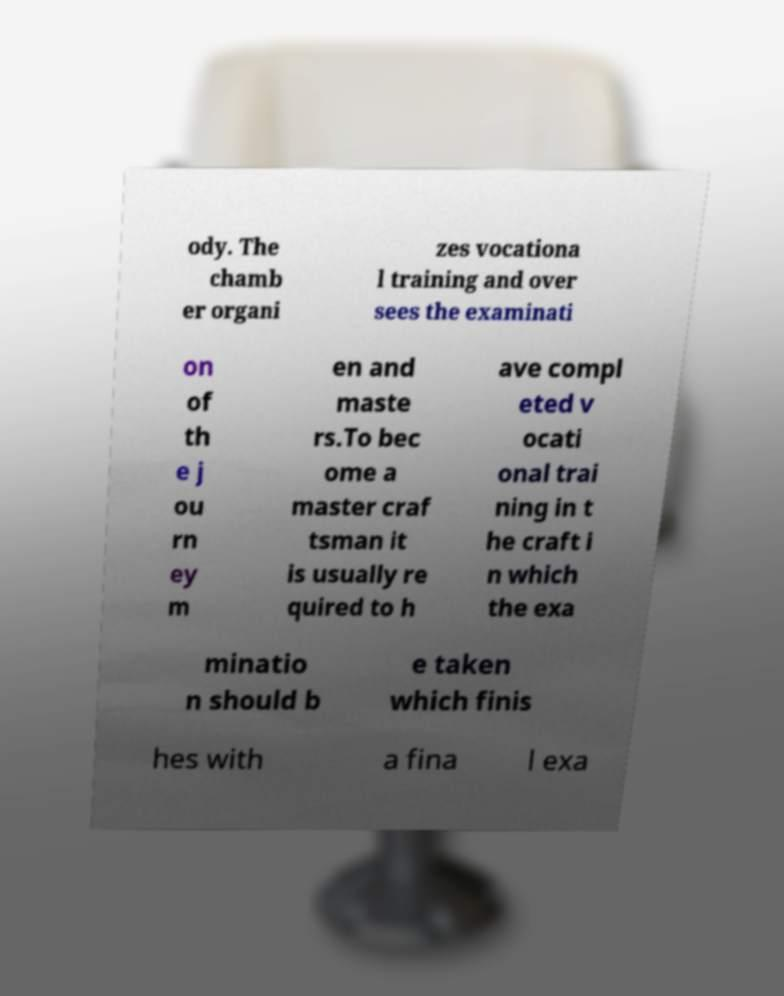Please read and relay the text visible in this image. What does it say? ody. The chamb er organi zes vocationa l training and over sees the examinati on of th e j ou rn ey m en and maste rs.To bec ome a master craf tsman it is usually re quired to h ave compl eted v ocati onal trai ning in t he craft i n which the exa minatio n should b e taken which finis hes with a fina l exa 